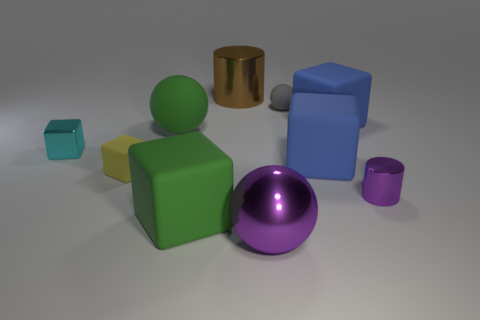Subtract all green cubes. How many cubes are left? 4 Subtract all yellow blocks. How many blocks are left? 4 Subtract all gray cubes. Subtract all green balls. How many cubes are left? 5 Subtract all yellow cubes. How many purple spheres are left? 1 Subtract all big blue cubes. Subtract all large green matte blocks. How many objects are left? 7 Add 4 yellow matte cubes. How many yellow matte cubes are left? 5 Add 9 brown cubes. How many brown cubes exist? 9 Subtract 1 gray spheres. How many objects are left? 9 Subtract all spheres. How many objects are left? 7 Subtract 1 balls. How many balls are left? 2 